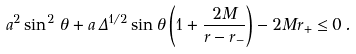<formula> <loc_0><loc_0><loc_500><loc_500>a ^ { 2 } \sin ^ { 2 } \, \theta + a \, \Delta ^ { 1 / 2 } \sin \theta \left ( 1 + \frac { 2 M } { r - r _ { - } } \right ) - 2 M r _ { + } \leq 0 \, .</formula> 